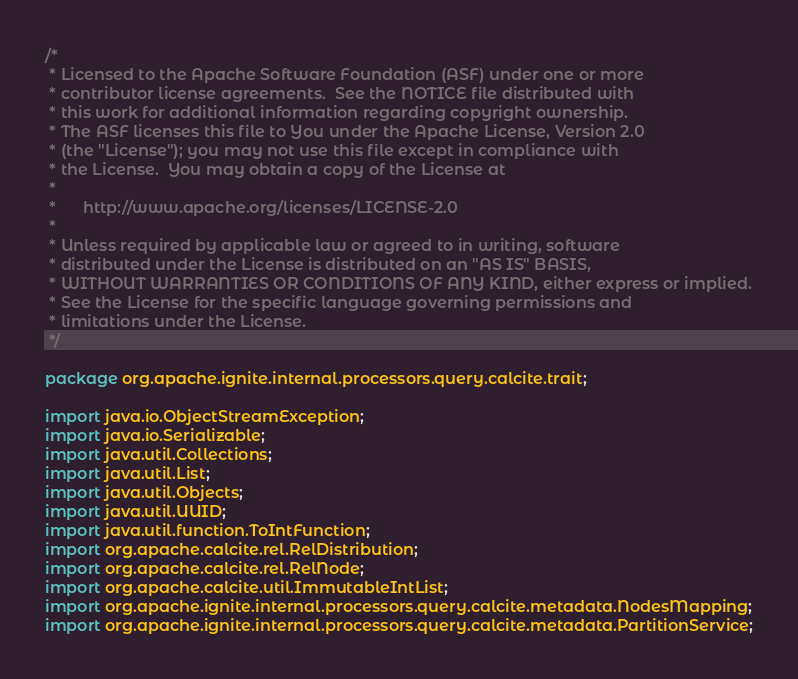<code> <loc_0><loc_0><loc_500><loc_500><_Java_>/*
 * Licensed to the Apache Software Foundation (ASF) under one or more
 * contributor license agreements.  See the NOTICE file distributed with
 * this work for additional information regarding copyright ownership.
 * The ASF licenses this file to You under the Apache License, Version 2.0
 * (the "License"); you may not use this file except in compliance with
 * the License.  You may obtain a copy of the License at
 *
 *      http://www.apache.org/licenses/LICENSE-2.0
 *
 * Unless required by applicable law or agreed to in writing, software
 * distributed under the License is distributed on an "AS IS" BASIS,
 * WITHOUT WARRANTIES OR CONDITIONS OF ANY KIND, either express or implied.
 * See the License for the specific language governing permissions and
 * limitations under the License.
 */

package org.apache.ignite.internal.processors.query.calcite.trait;

import java.io.ObjectStreamException;
import java.io.Serializable;
import java.util.Collections;
import java.util.List;
import java.util.Objects;
import java.util.UUID;
import java.util.function.ToIntFunction;
import org.apache.calcite.rel.RelDistribution;
import org.apache.calcite.rel.RelNode;
import org.apache.calcite.util.ImmutableIntList;
import org.apache.ignite.internal.processors.query.calcite.metadata.NodesMapping;
import org.apache.ignite.internal.processors.query.calcite.metadata.PartitionService;</code> 